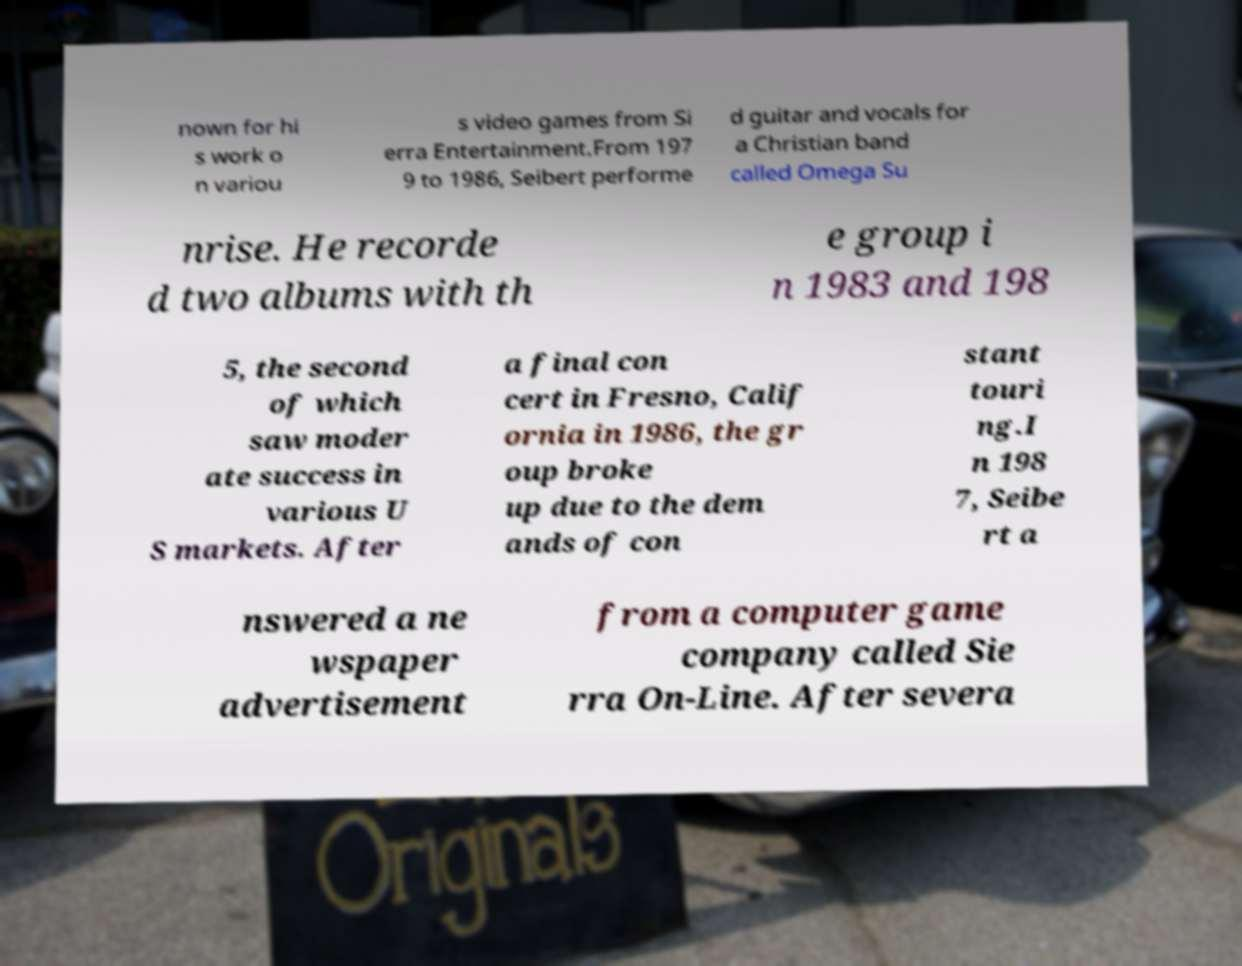Please read and relay the text visible in this image. What does it say? nown for hi s work o n variou s video games from Si erra Entertainment.From 197 9 to 1986, Seibert performe d guitar and vocals for a Christian band called Omega Su nrise. He recorde d two albums with th e group i n 1983 and 198 5, the second of which saw moder ate success in various U S markets. After a final con cert in Fresno, Calif ornia in 1986, the gr oup broke up due to the dem ands of con stant touri ng.I n 198 7, Seibe rt a nswered a ne wspaper advertisement from a computer game company called Sie rra On-Line. After severa 